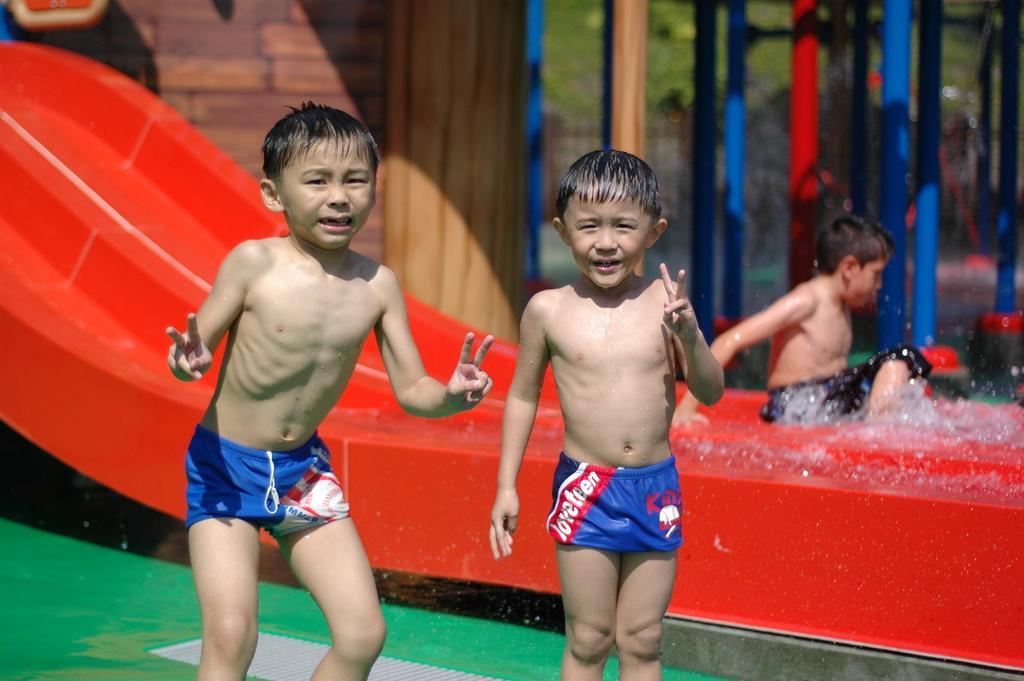How would you summarize this image in a sentence or two? In this image I can see two persons standing. In the background I can see the water slide, few poles in multi color and trees in green color and I can also see the person sitting. 